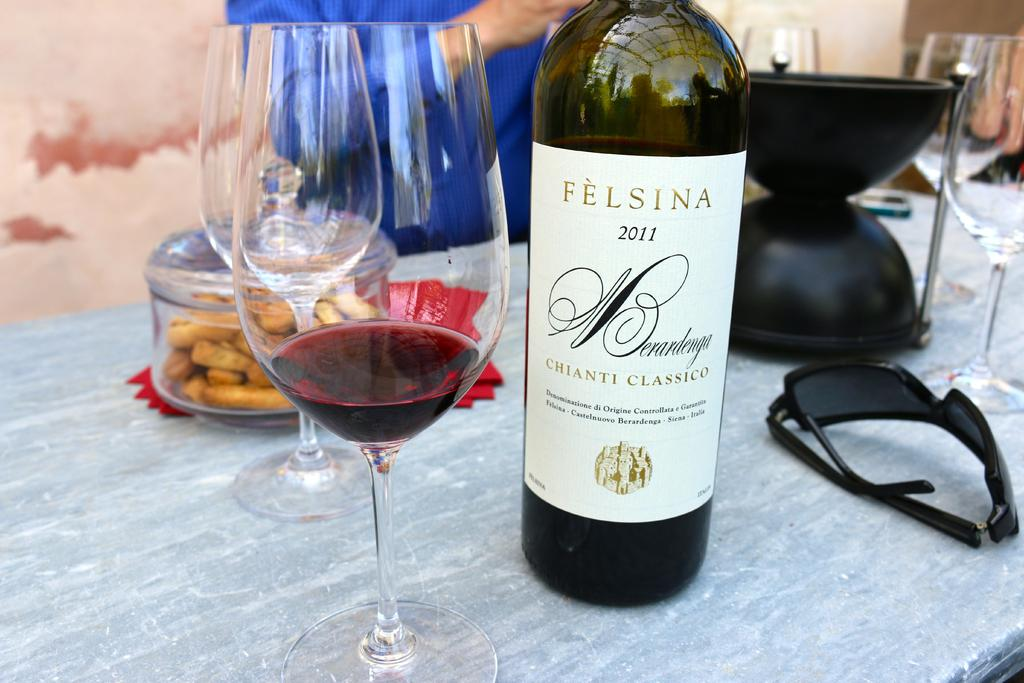<image>
Share a concise interpretation of the image provided. A bottle of "FELSINA" Chianti is on a table. 